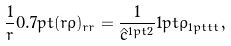Convert formula to latex. <formula><loc_0><loc_0><loc_500><loc_500>\frac { 1 } { r } 0 . 7 p t ( r \varrho ) _ { r r } = \frac { 1 } { \hat { c } ^ { 1 p t 2 } } 1 p t \varrho _ { 1 p t t t } ,</formula> 